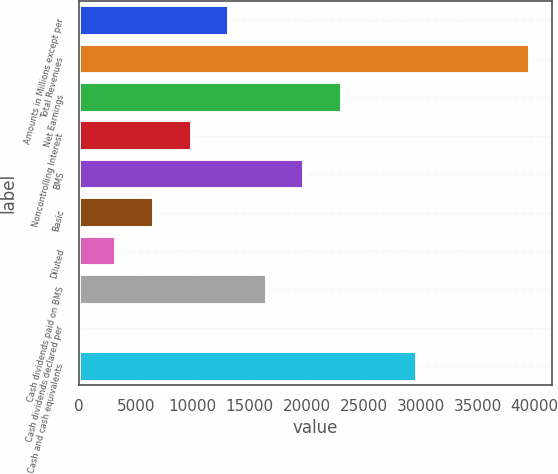Convert chart. <chart><loc_0><loc_0><loc_500><loc_500><bar_chart><fcel>Amounts in Millions except per<fcel>Total Revenues<fcel>Net Earnings<fcel>Noncontrolling Interest<fcel>BMS<fcel>Basic<fcel>Diluted<fcel>Cash dividends paid on BMS<fcel>Cash dividends declared per<fcel>Cash and cash equivalents<nl><fcel>13188.8<fcel>39563.8<fcel>23079.4<fcel>9891.94<fcel>19782.5<fcel>6595.07<fcel>3298.2<fcel>16485.7<fcel>1.33<fcel>29673.2<nl></chart> 